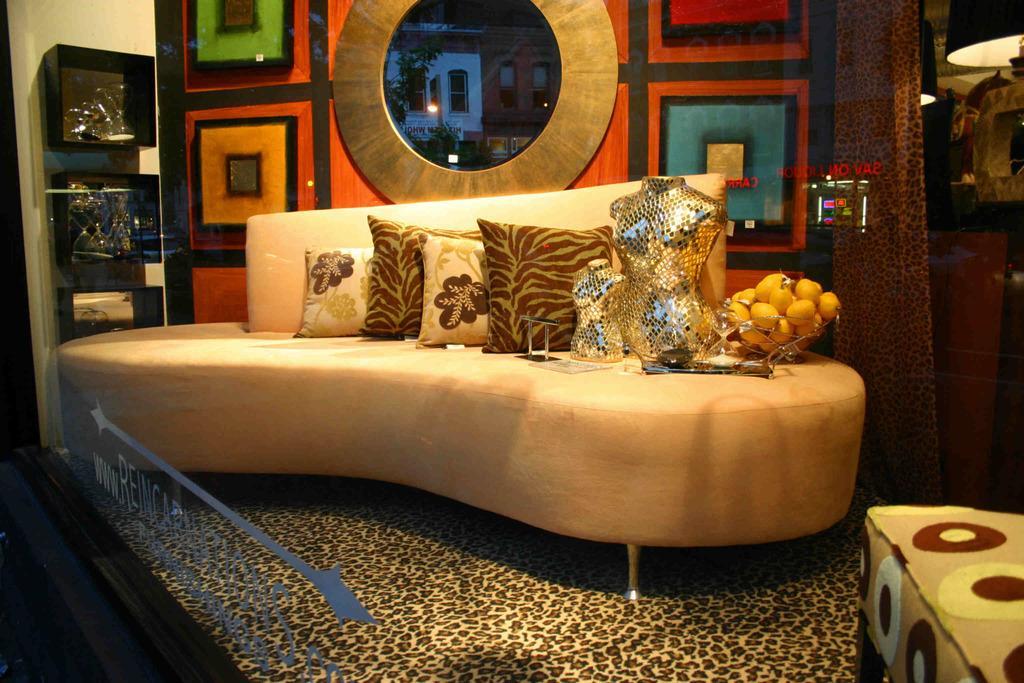How would you summarize this image in a sentence or two? In this picture there is sofa with few pillows,two mannequins and a bowl of fruits on it. It is kept to showcase home environment with few architecture patterns behind it. 